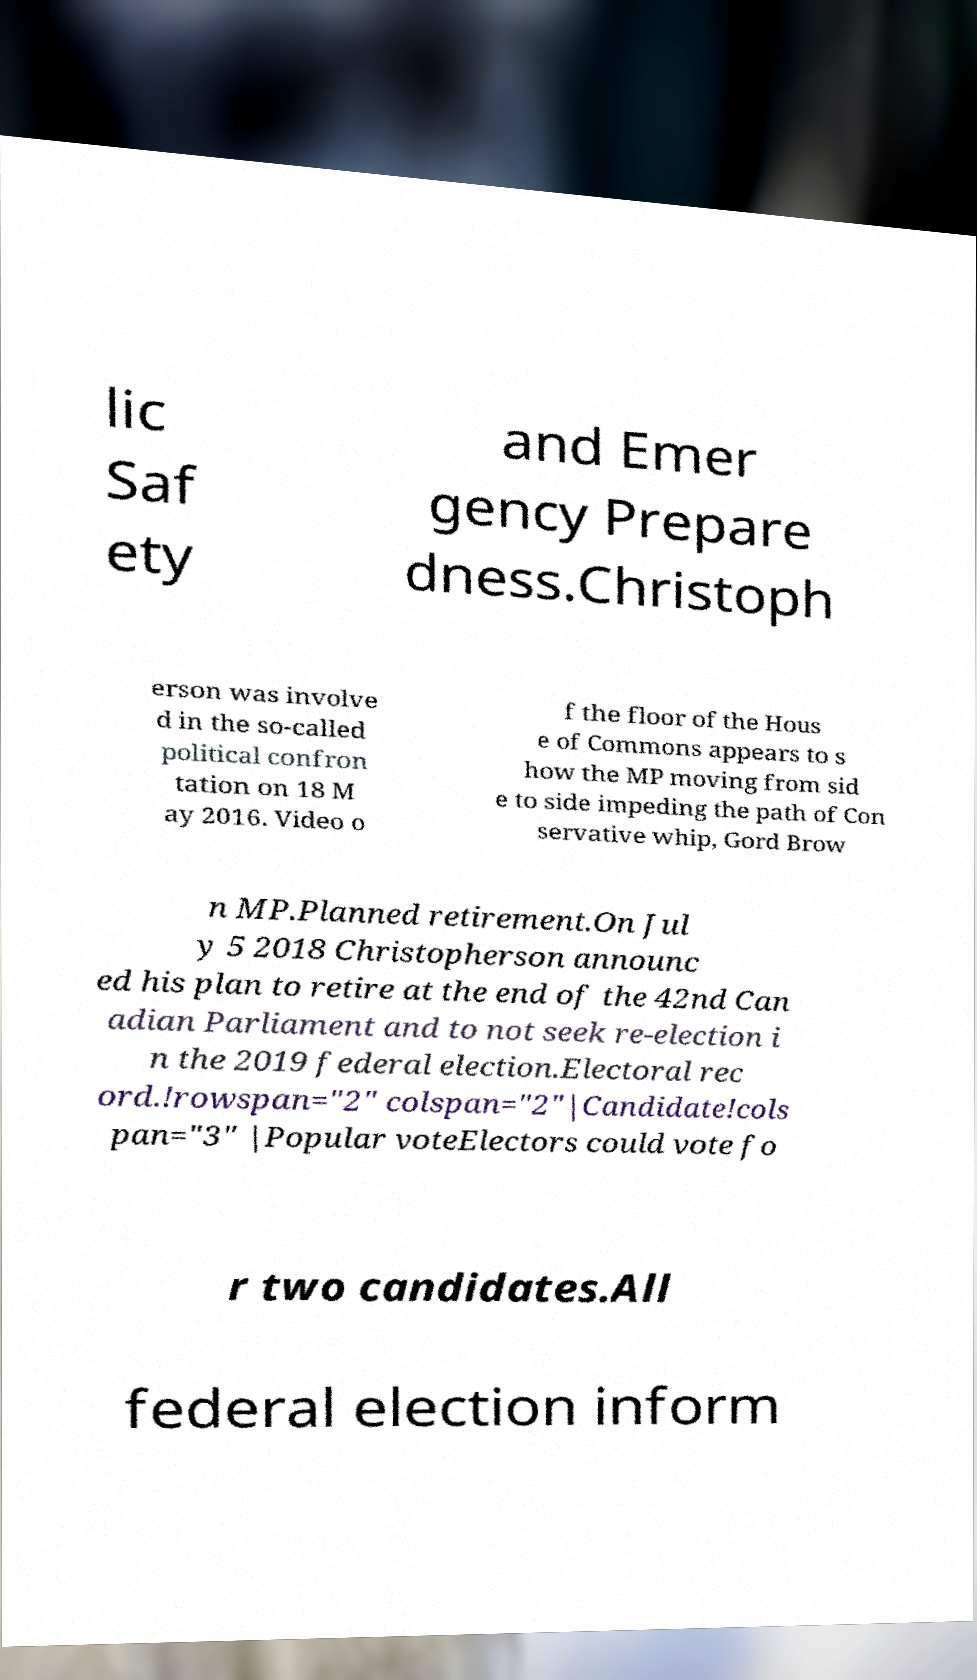For documentation purposes, I need the text within this image transcribed. Could you provide that? lic Saf ety and Emer gency Prepare dness.Christoph erson was involve d in the so-called political confron tation on 18 M ay 2016. Video o f the floor of the Hous e of Commons appears to s how the MP moving from sid e to side impeding the path of Con servative whip, Gord Brow n MP.Planned retirement.On Jul y 5 2018 Christopherson announc ed his plan to retire at the end of the 42nd Can adian Parliament and to not seek re-election i n the 2019 federal election.Electoral rec ord.!rowspan="2" colspan="2"|Candidate!cols pan="3" |Popular voteElectors could vote fo r two candidates.All federal election inform 